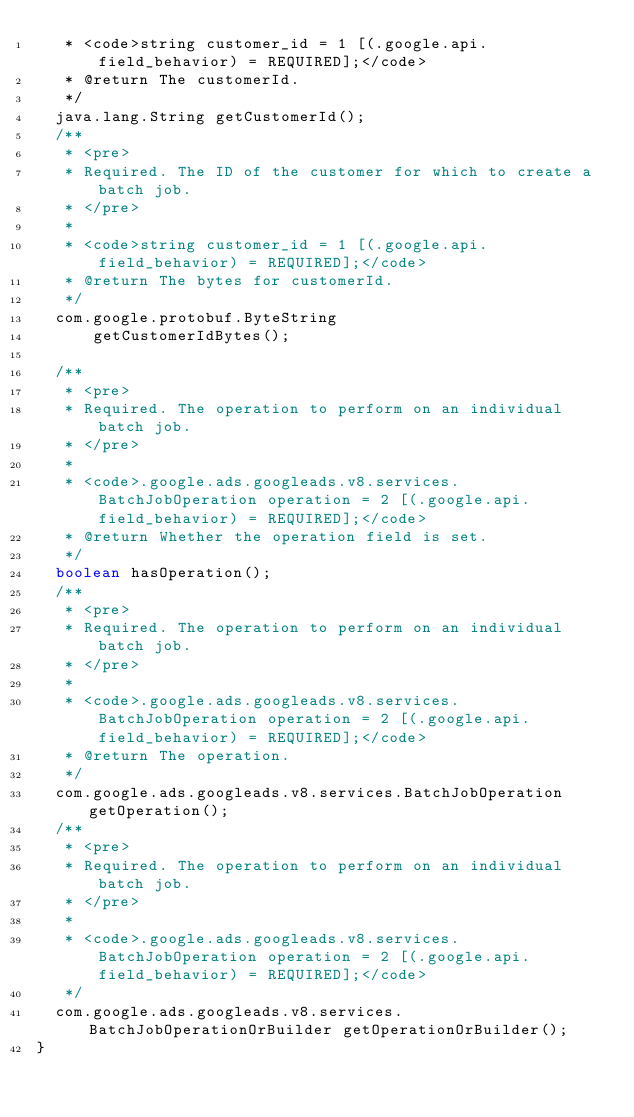Convert code to text. <code><loc_0><loc_0><loc_500><loc_500><_Java_>   * <code>string customer_id = 1 [(.google.api.field_behavior) = REQUIRED];</code>
   * @return The customerId.
   */
  java.lang.String getCustomerId();
  /**
   * <pre>
   * Required. The ID of the customer for which to create a batch job.
   * </pre>
   *
   * <code>string customer_id = 1 [(.google.api.field_behavior) = REQUIRED];</code>
   * @return The bytes for customerId.
   */
  com.google.protobuf.ByteString
      getCustomerIdBytes();

  /**
   * <pre>
   * Required. The operation to perform on an individual batch job.
   * </pre>
   *
   * <code>.google.ads.googleads.v8.services.BatchJobOperation operation = 2 [(.google.api.field_behavior) = REQUIRED];</code>
   * @return Whether the operation field is set.
   */
  boolean hasOperation();
  /**
   * <pre>
   * Required. The operation to perform on an individual batch job.
   * </pre>
   *
   * <code>.google.ads.googleads.v8.services.BatchJobOperation operation = 2 [(.google.api.field_behavior) = REQUIRED];</code>
   * @return The operation.
   */
  com.google.ads.googleads.v8.services.BatchJobOperation getOperation();
  /**
   * <pre>
   * Required. The operation to perform on an individual batch job.
   * </pre>
   *
   * <code>.google.ads.googleads.v8.services.BatchJobOperation operation = 2 [(.google.api.field_behavior) = REQUIRED];</code>
   */
  com.google.ads.googleads.v8.services.BatchJobOperationOrBuilder getOperationOrBuilder();
}
</code> 